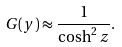<formula> <loc_0><loc_0><loc_500><loc_500>G ( y ) \approx \frac { 1 } { \cosh ^ { 2 } z } .</formula> 